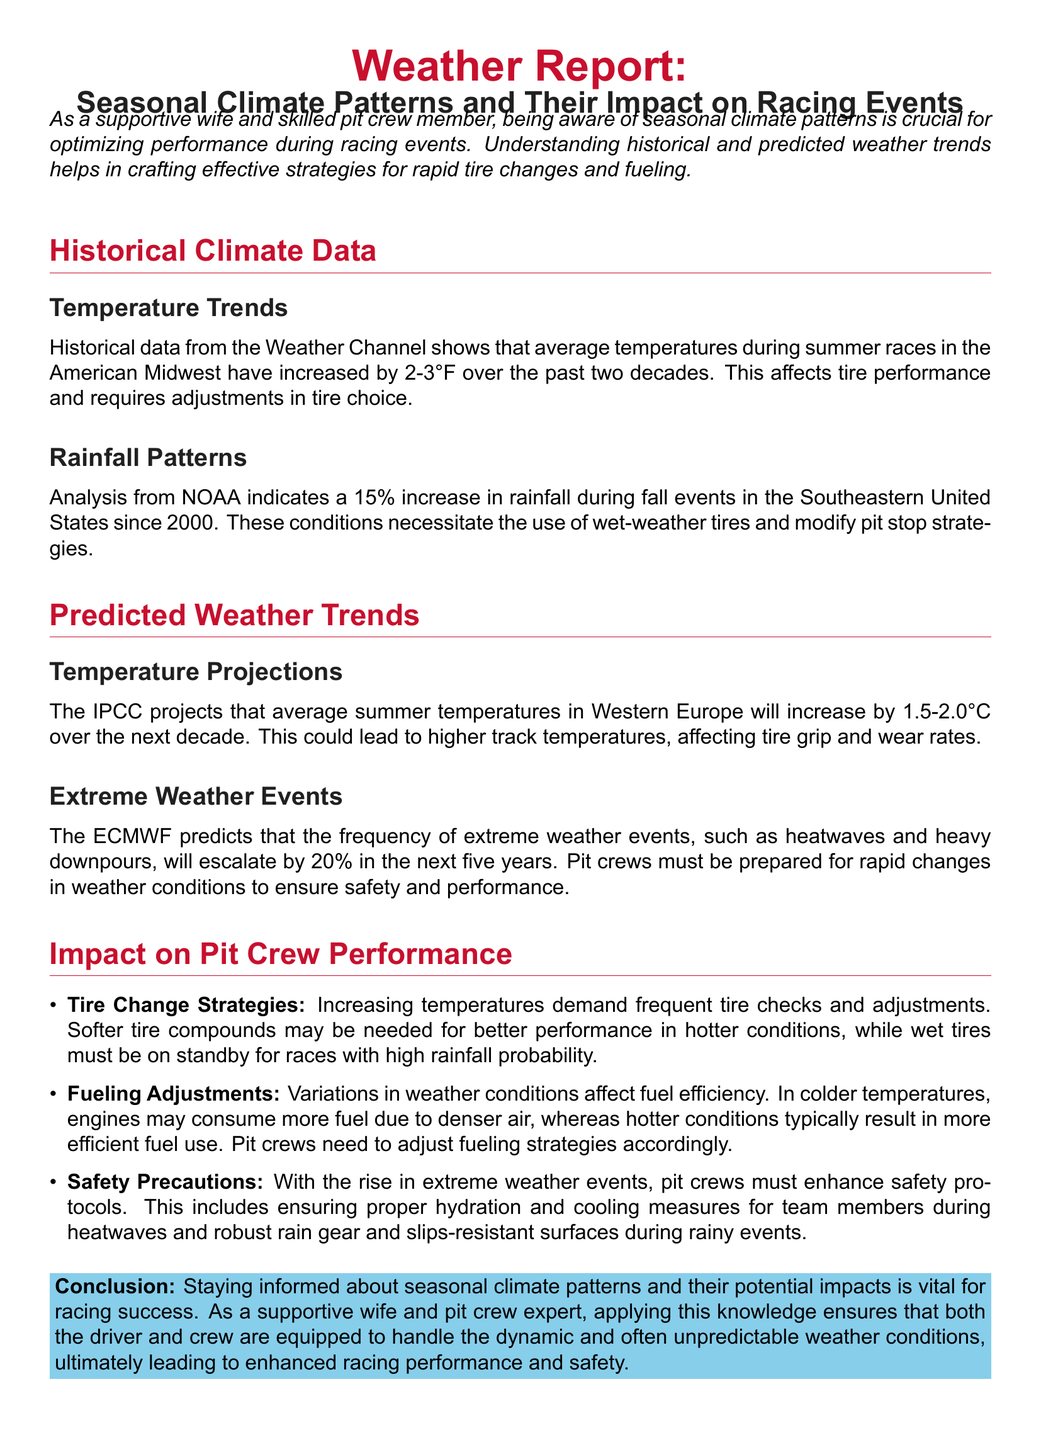what is the temperature increase during summer races in the American Midwest? Historical data states that average temperatures have increased by 2-3°F over the past two decades.
Answer: 2-3°F what is the percentage increase in rainfall during fall events in the Southeastern United States? Analysis indicates a 15% increase in rainfall during fall events since 2000.
Answer: 15% what is the projected temperature increase in Western Europe over the next decade? The IPCC projects an increase of 1.5-2.0°C in average summer temperatures.
Answer: 1.5-2.0°C what is the predicted increase in the frequency of extreme weather events in the next five years? The ECMWF predicts an escalation of extreme weather events by 20%.
Answer: 20% what type of tires must be on standby for rainy events? The document states that wet tires must be on standby for races with high rainfall probability.
Answer: Wet tires what should pit crews enhance during extreme weather events? The document highlights that pit crews must enhance safety protocols during extreme weather events.
Answer: Safety protocols how does colder temperature affect engine fuel consumption? In colder temperatures, engines may consume more fuel due to denser air.
Answer: More fuel what is a crucial strategy for tire changes in increasing temperatures? The document specifies that increasing temperatures demand frequent tire checks and adjustments.
Answer: Frequent checks what should pit crews ensure during heatwaves for safety? The document notes that proper hydration and cooling measures should be ensured for team members during heatwaves.
Answer: Proper hydration and cooling measures 